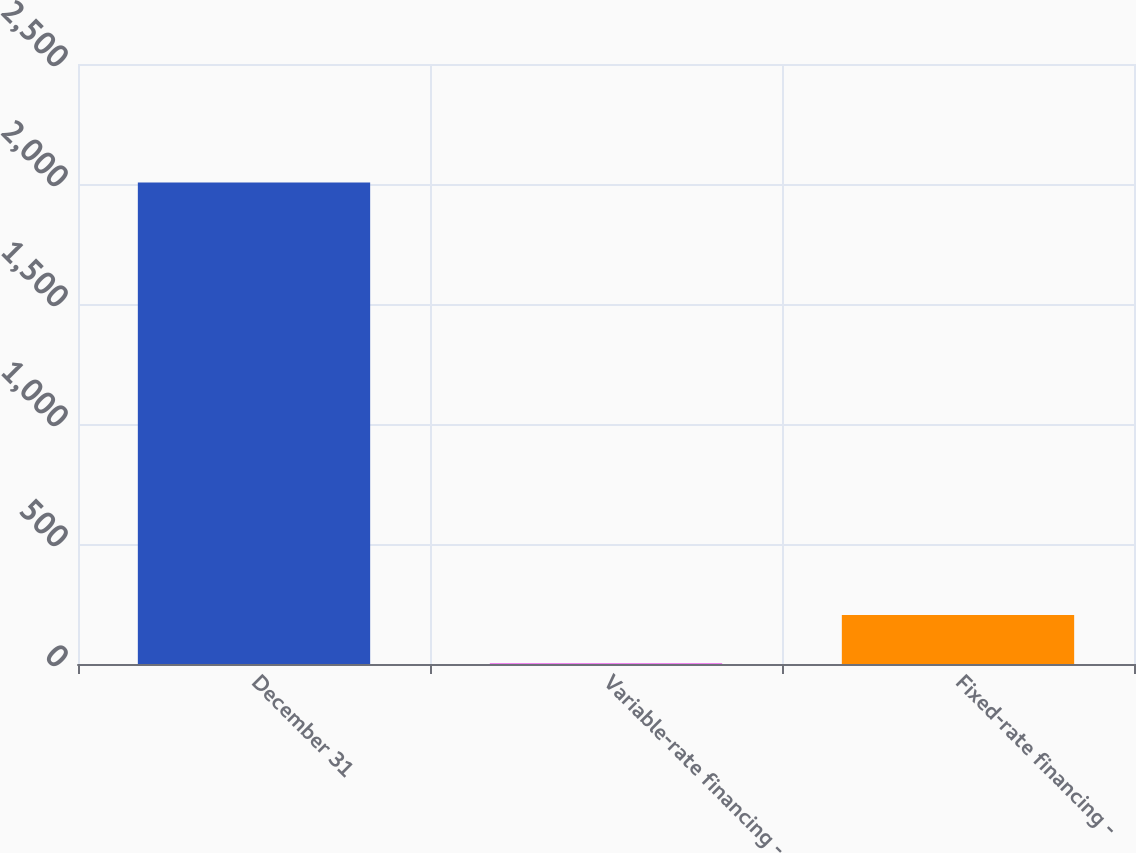<chart> <loc_0><loc_0><loc_500><loc_500><bar_chart><fcel>December 31<fcel>Variable-rate financing -<fcel>Fixed-rate financing -<nl><fcel>2006<fcel>4<fcel>204.2<nl></chart> 